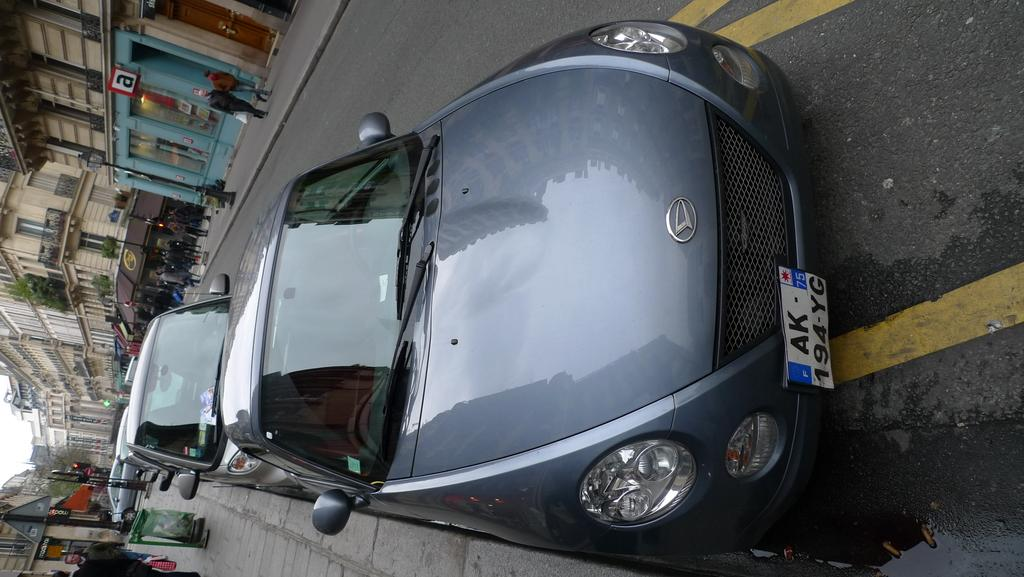Provide a one-sentence caption for the provided image. A parked car with license plate 194 YG. 